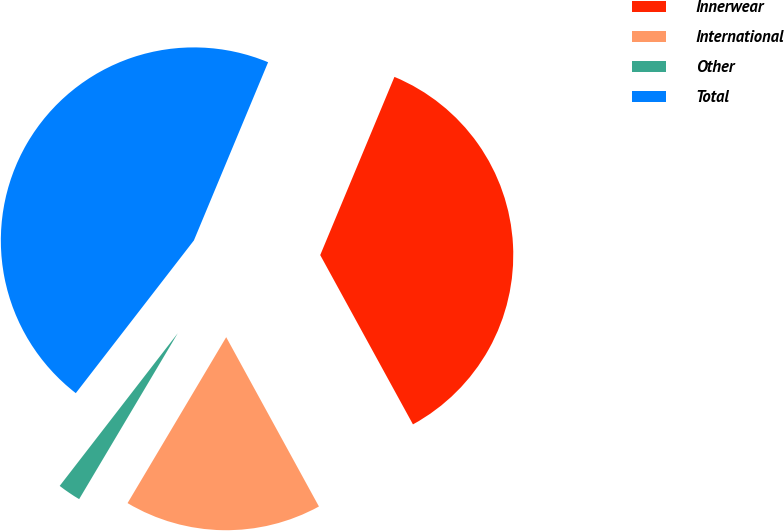Convert chart. <chart><loc_0><loc_0><loc_500><loc_500><pie_chart><fcel>Innerwear<fcel>International<fcel>Other<fcel>Total<nl><fcel>35.74%<fcel>16.51%<fcel>1.94%<fcel>45.8%<nl></chart> 